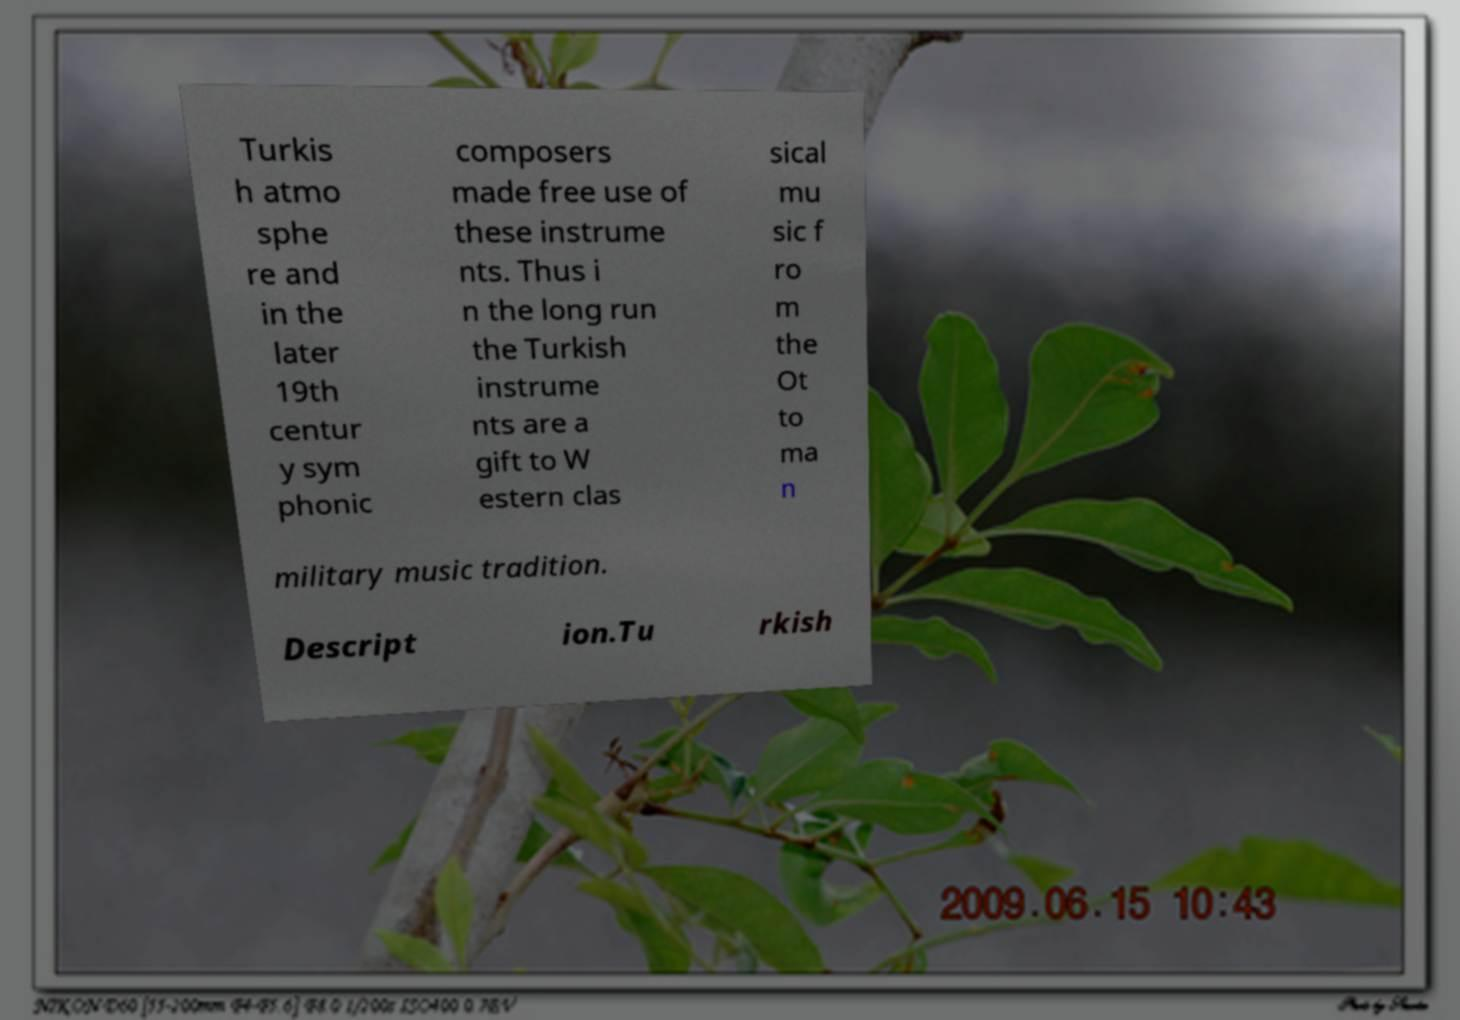Please identify and transcribe the text found in this image. Turkis h atmo sphe re and in the later 19th centur y sym phonic composers made free use of these instrume nts. Thus i n the long run the Turkish instrume nts are a gift to W estern clas sical mu sic f ro m the Ot to ma n military music tradition. Descript ion.Tu rkish 